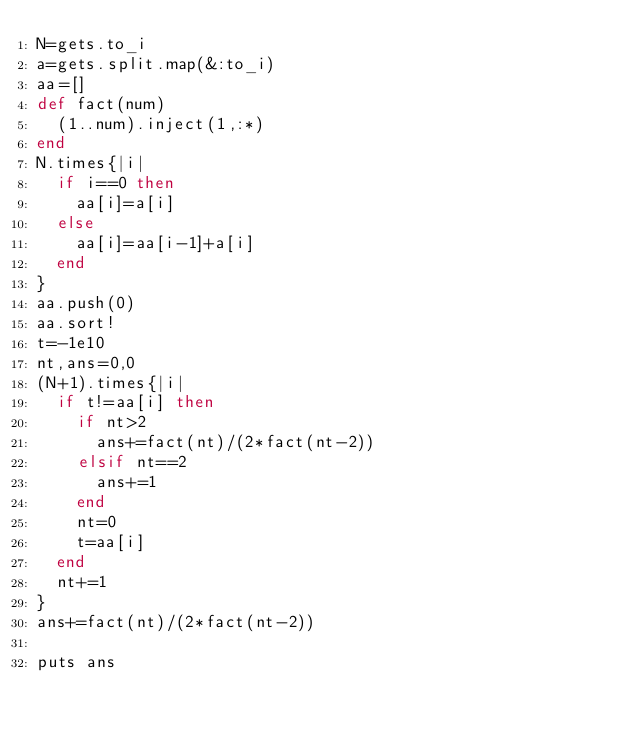Convert code to text. <code><loc_0><loc_0><loc_500><loc_500><_Ruby_>N=gets.to_i
a=gets.split.map(&:to_i)
aa=[]
def fact(num)
  (1..num).inject(1,:*)
end
N.times{|i|
  if i==0 then
    aa[i]=a[i]
  else
    aa[i]=aa[i-1]+a[i]
  end
}
aa.push(0)
aa.sort!
t=-1e10
nt,ans=0,0
(N+1).times{|i|
  if t!=aa[i] then
    if nt>2
      ans+=fact(nt)/(2*fact(nt-2))
    elsif nt==2
      ans+=1
    end
    nt=0
    t=aa[i]
  end
  nt+=1
}
ans+=fact(nt)/(2*fact(nt-2))

puts ans
</code> 